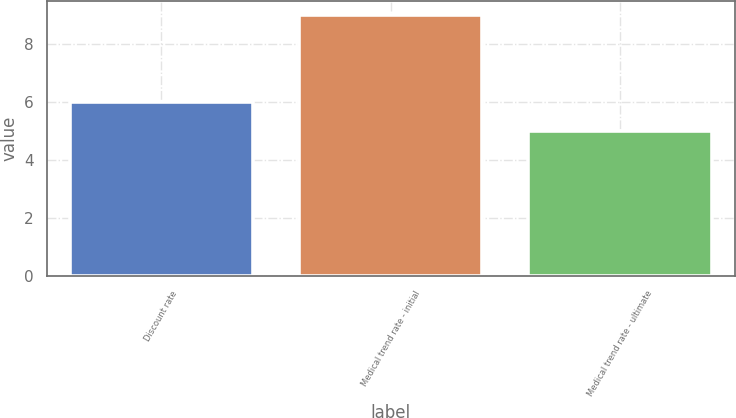Convert chart. <chart><loc_0><loc_0><loc_500><loc_500><bar_chart><fcel>Discount rate<fcel>Medical trend rate - initial<fcel>Medical trend rate - ultimate<nl><fcel>6<fcel>9<fcel>5<nl></chart> 